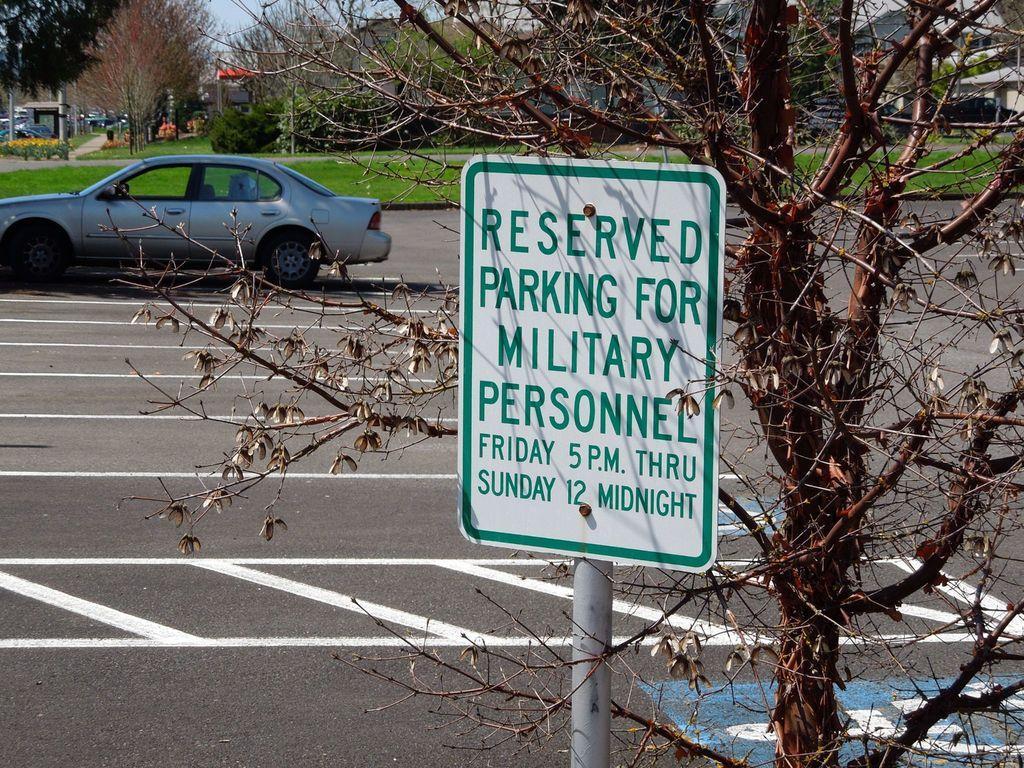Please provide a concise description of this image. In the center of the image we can see sign board on the road. In the background we can see trees, car, road, houses, plants and sky. 